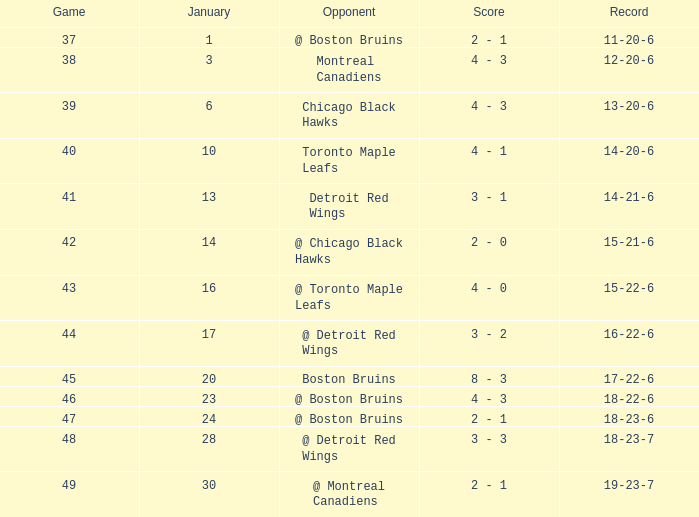What day in January was the game greater than 49 and had @ Montreal Canadiens as opponents? None. 